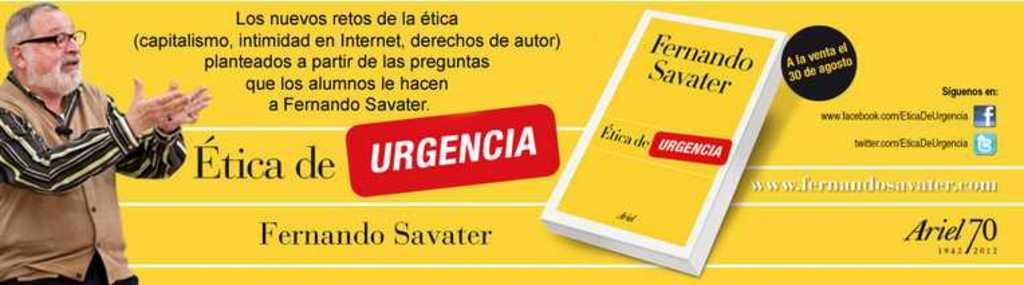<image>
Describe the image concisely. A book by Ferndando Savater called Etica de Urgencia 